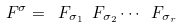Convert formula to latex. <formula><loc_0><loc_0><loc_500><loc_500>\ F ^ { \sigma } = \ F _ { \sigma _ { 1 } } \ F _ { \sigma _ { 2 } } \cdots \ F _ { \sigma _ { r } }</formula> 